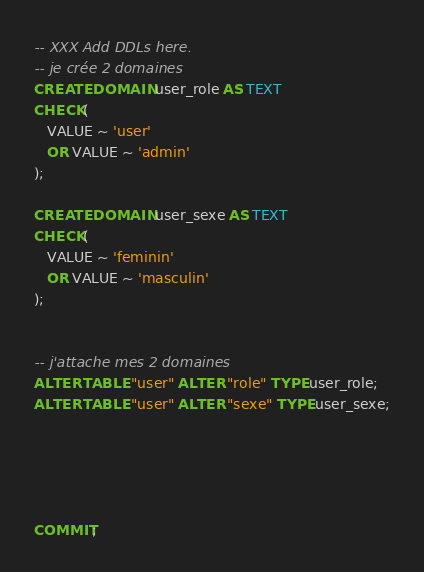<code> <loc_0><loc_0><loc_500><loc_500><_SQL_>-- XXX Add DDLs here.
-- je crée 2 domaines
CREATE DOMAIN user_role AS TEXT
CHECK(
   VALUE ~ 'user'
   OR VALUE ~ 'admin'
);

CREATE DOMAIN user_sexe AS TEXT
CHECK(
   VALUE ~ 'feminin'
   OR VALUE ~ 'masculin'
);


-- j'attache mes 2 domaines
ALTER TABLE "user" ALTER "role" TYPE user_role;
ALTER TABLE "user" ALTER "sexe" TYPE user_sexe;





COMMIT;
</code> 